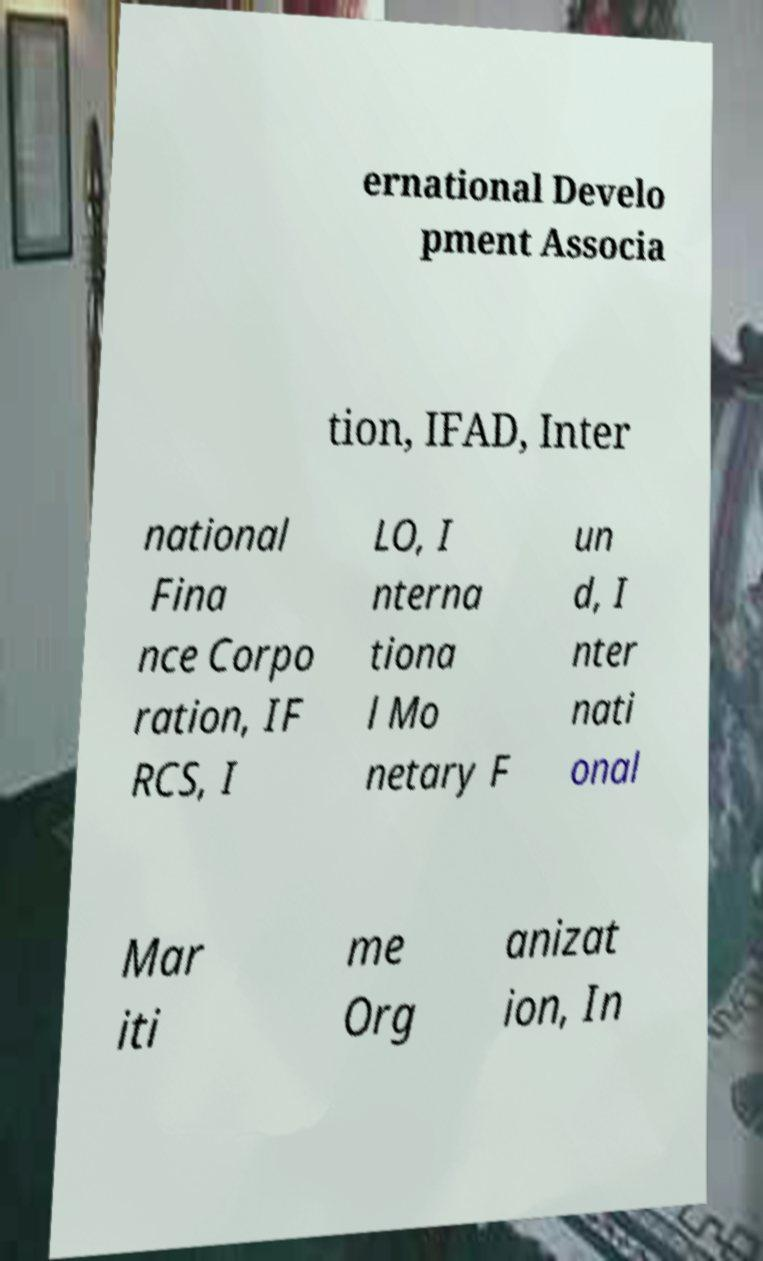There's text embedded in this image that I need extracted. Can you transcribe it verbatim? ernational Develo pment Associa tion, IFAD, Inter national Fina nce Corpo ration, IF RCS, I LO, I nterna tiona l Mo netary F un d, I nter nati onal Mar iti me Org anizat ion, In 